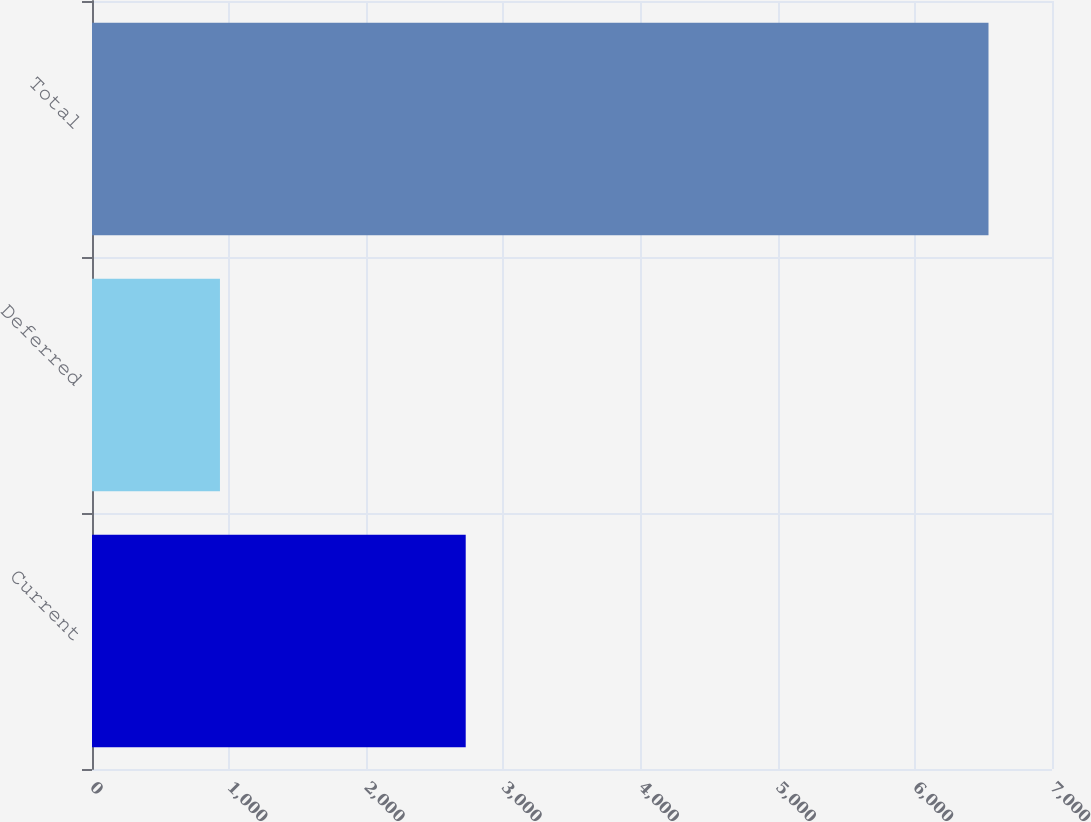Convert chart. <chart><loc_0><loc_0><loc_500><loc_500><bar_chart><fcel>Current<fcel>Deferred<fcel>Total<nl><fcel>2725<fcel>933<fcel>6537<nl></chart> 